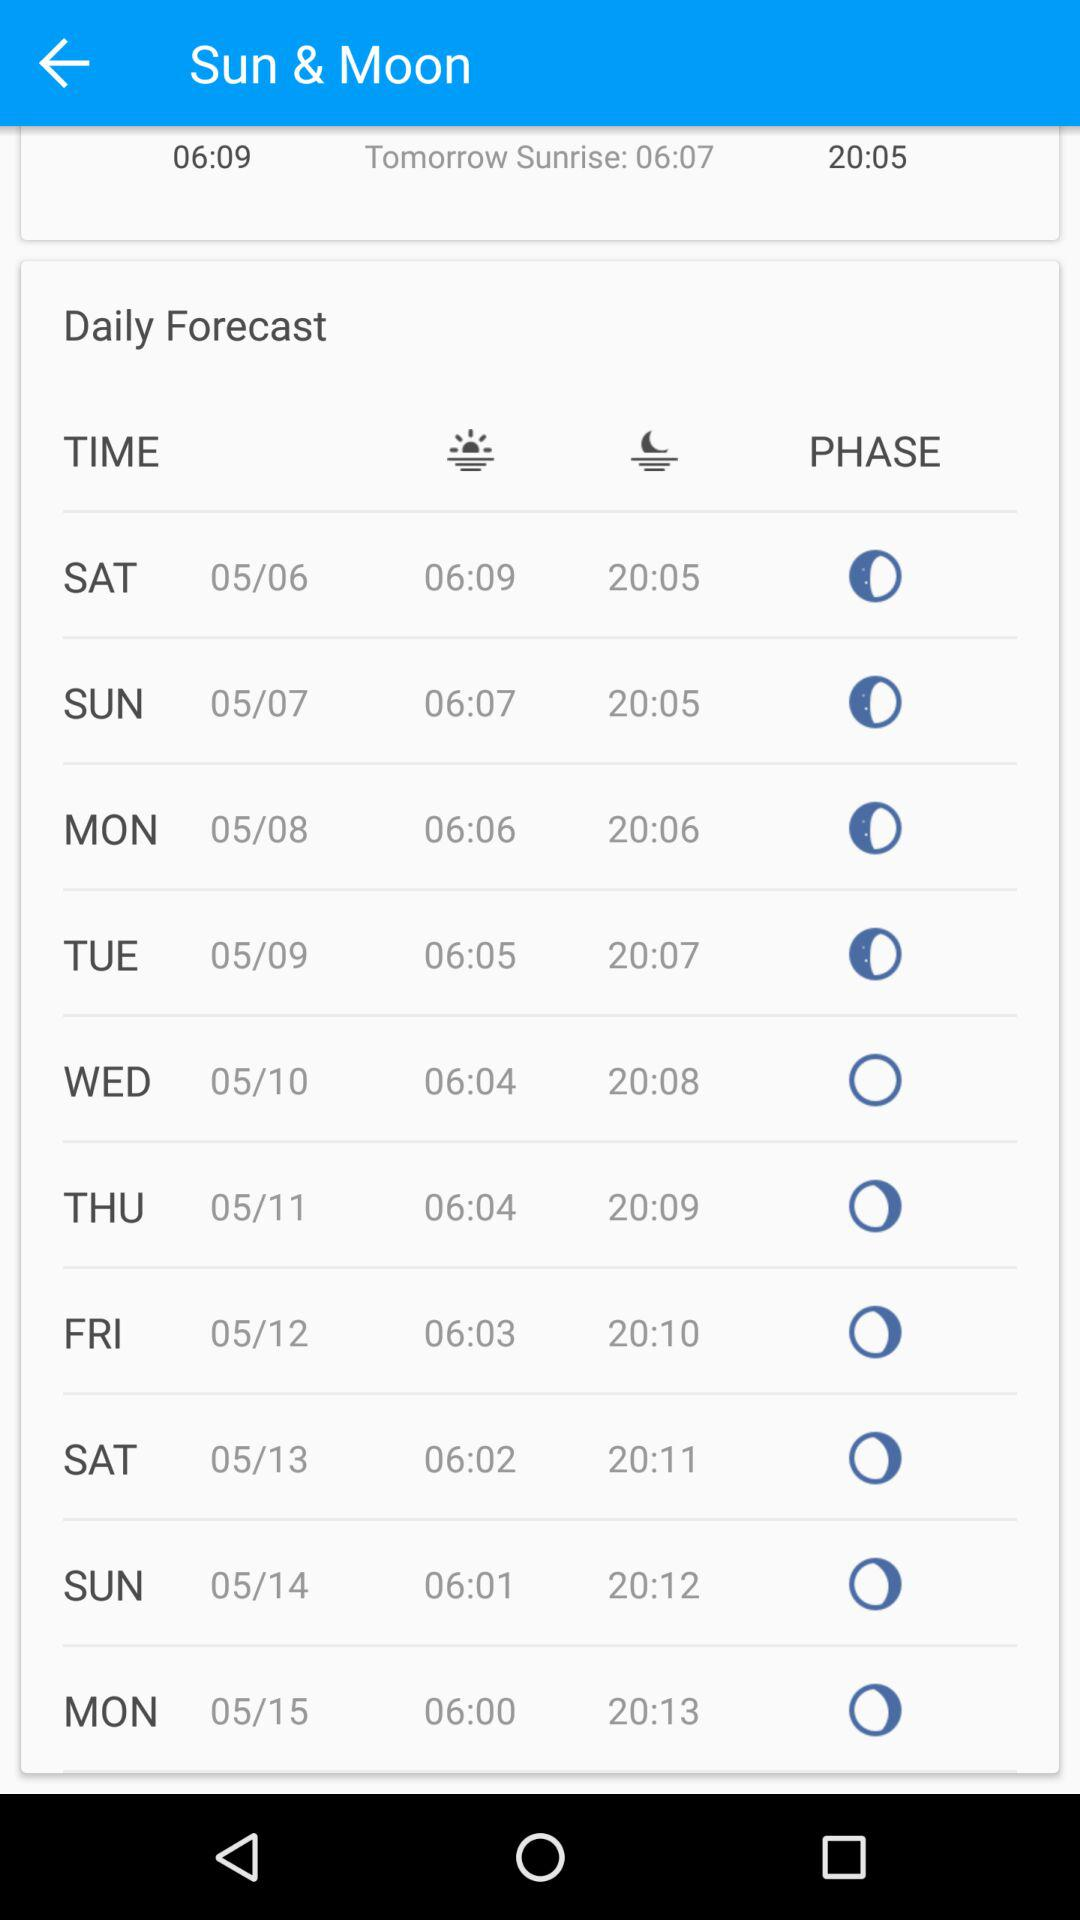What is the sunset time on Sunday, 7th of May? The sunset time is 20:05. 